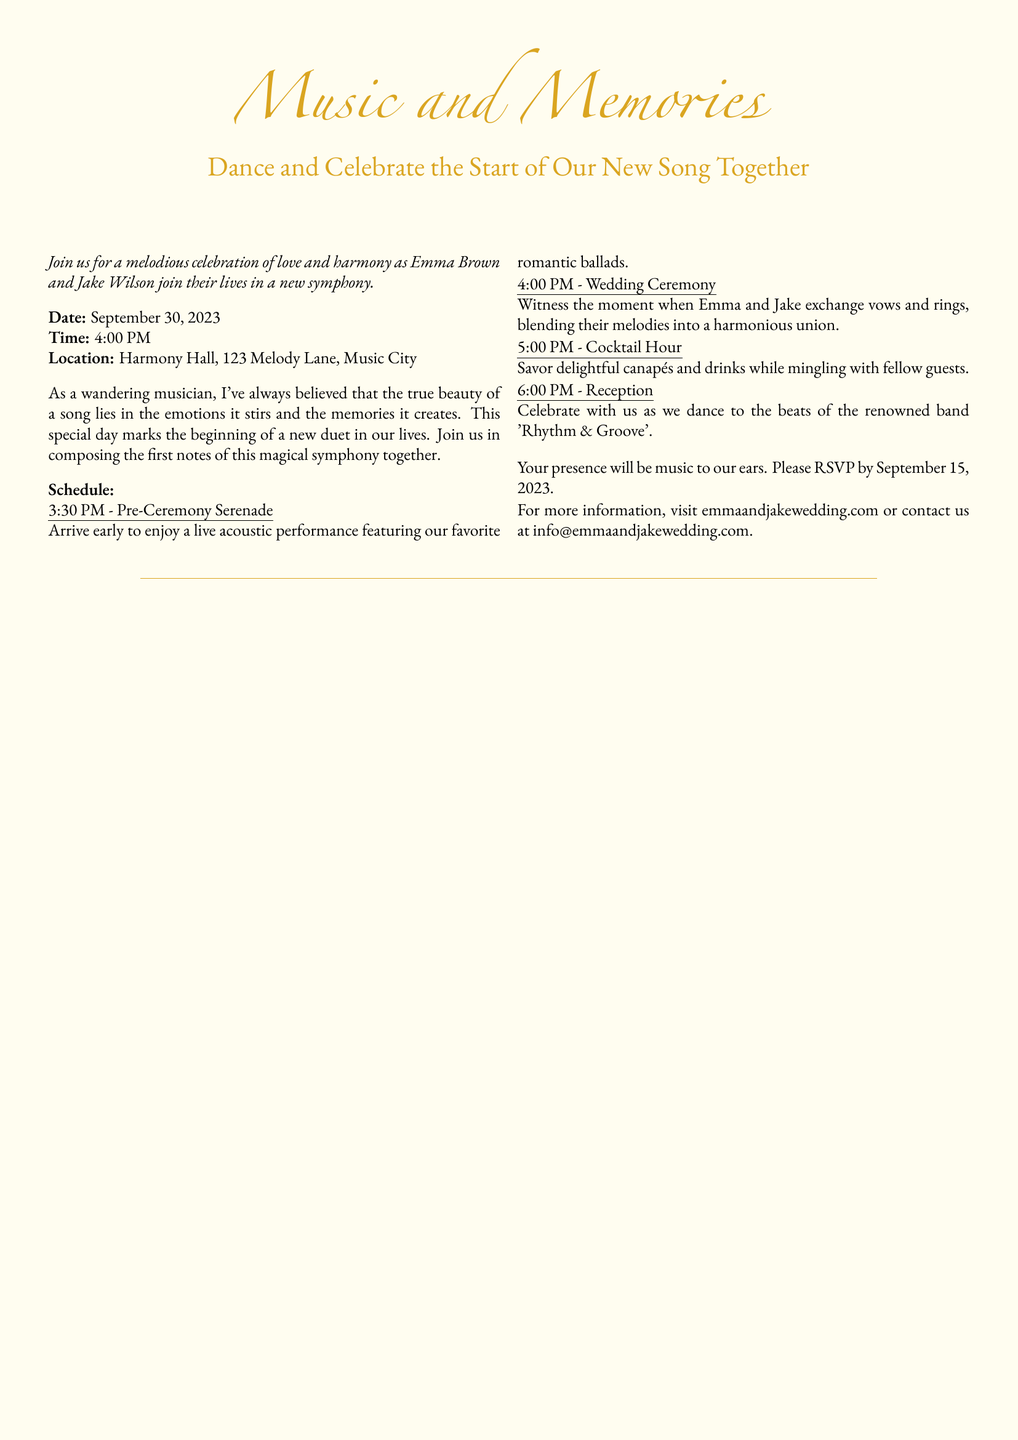what are the names of the couple? The document mentions the names of the couple as Emma Brown and Jake Wilson.
Answer: Emma Brown and Jake Wilson what is the date of the wedding? The document states the wedding date as September 30, 2023.
Answer: September 30, 2023 what time does the wedding ceremony start? The document specifies that the wedding ceremony will start at 4:00 PM.
Answer: 4:00 PM where is the wedding taking place? The wedding location is provided in the document as Harmony Hall, 123 Melody Lane, Music City.
Answer: Harmony Hall, 123 Melody Lane, Music City what is scheduled at 3:30 PM? The document states that a Pre-Ceremony Serenade is scheduled at 3:30 PM.
Answer: Pre-Ceremony Serenade who is performing at the reception? The document mentions that the band 'Rhythm & Groove' will be performing at the reception.
Answer: Rhythm & Groove what kind of performance is expected before the ceremony? The document describes the pre-ceremony entertainment as a live acoustic performance featuring romantic ballads.
Answer: live acoustic performance when should guests RSVP by? According to the document, guests should RSVP by September 15, 2023.
Answer: September 15, 2023 what is the theme of the invitation? The document emphasizes a theme of music and memories celebrating love and harmony.
Answer: Music and Memories 